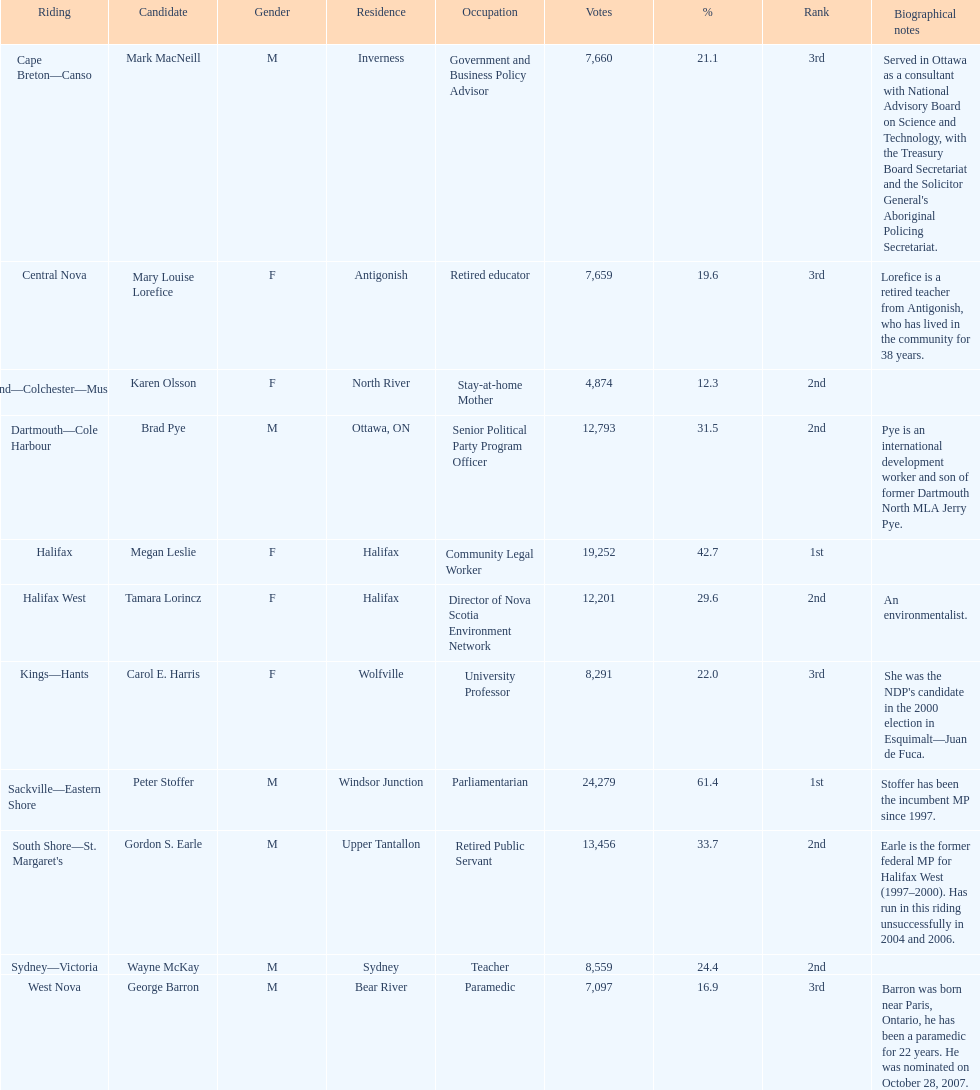Help me parse the entirety of this table. {'header': ['Riding', 'Candidate', 'Gender', 'Residence', 'Occupation', 'Votes', '%', 'Rank', 'Biographical notes'], 'rows': [['Cape Breton—Canso', 'Mark MacNeill', 'M', 'Inverness', 'Government and Business Policy Advisor', '7,660', '21.1', '3rd', "Served in Ottawa as a consultant with National Advisory Board on Science and Technology, with the Treasury Board Secretariat and the Solicitor General's Aboriginal Policing Secretariat."], ['Central Nova', 'Mary Louise Lorefice', 'F', 'Antigonish', 'Retired educator', '7,659', '19.6', '3rd', 'Lorefice is a retired teacher from Antigonish, who has lived in the community for 38 years.'], ['Cumberland—Colchester—Musquodoboit Valley', 'Karen Olsson', 'F', 'North River', 'Stay-at-home Mother', '4,874', '12.3', '2nd', ''], ['Dartmouth—Cole Harbour', 'Brad Pye', 'M', 'Ottawa, ON', 'Senior Political Party Program Officer', '12,793', '31.5', '2nd', 'Pye is an international development worker and son of former Dartmouth North MLA Jerry Pye.'], ['Halifax', 'Megan Leslie', 'F', 'Halifax', 'Community Legal Worker', '19,252', '42.7', '1st', ''], ['Halifax West', 'Tamara Lorincz', 'F', 'Halifax', 'Director of Nova Scotia Environment Network', '12,201', '29.6', '2nd', 'An environmentalist.'], ['Kings—Hants', 'Carol E. Harris', 'F', 'Wolfville', 'University Professor', '8,291', '22.0', '3rd', "She was the NDP's candidate in the 2000 election in Esquimalt—Juan de Fuca."], ['Sackville—Eastern Shore', 'Peter Stoffer', 'M', 'Windsor Junction', 'Parliamentarian', '24,279', '61.4', '1st', 'Stoffer has been the incumbent MP since 1997.'], ["South Shore—St. Margaret's", 'Gordon S. Earle', 'M', 'Upper Tantallon', 'Retired Public Servant', '13,456', '33.7', '2nd', 'Earle is the former federal MP for Halifax West (1997–2000). Has run in this riding unsuccessfully in 2004 and 2006.'], ['Sydney—Victoria', 'Wayne McKay', 'M', 'Sydney', 'Teacher', '8,559', '24.4', '2nd', ''], ['West Nova', 'George Barron', 'M', 'Bear River', 'Paramedic', '7,097', '16.9', '3rd', 'Barron was born near Paris, Ontario, he has been a paramedic for 22 years. He was nominated on October 28, 2007.']]} What new democratic party candidates ran in the 2008 canadian federal election? Mark MacNeill, Mary Louise Lorefice, Karen Olsson, Brad Pye, Megan Leslie, Tamara Lorincz, Carol E. Harris, Peter Stoffer, Gordon S. Earle, Wayne McKay, George Barron. Of these candidates, which are female? Mary Louise Lorefice, Karen Olsson, Megan Leslie, Tamara Lorincz, Carol E. Harris. Which of these candidates resides in halifax? Megan Leslie, Tamara Lorincz. Of the remaining two, which was ranked 1st? Megan Leslie. How many votes did she get? 19,252. 